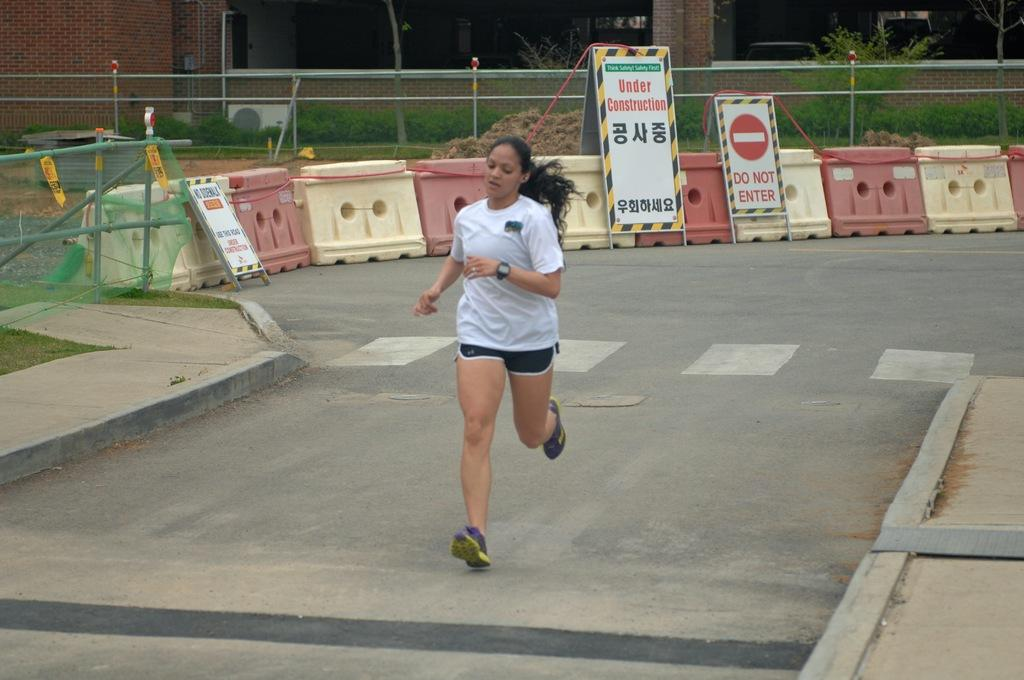Who is the main subject in the image? There is a woman in the image. What is the woman wearing? The woman is wearing a white t-shirt. What is the woman doing in the image? The woman is running on a path. What objects can be seen in the image related to traffic control? There are plastic traffic barriers in the image. What other objects can be seen in the image? There are boards and a fence in the image. What type of natural elements are present in the image? There are plants in the image. What type of man-made structure is visible in the image? There is a building in the image. What type of ice can be seen melting on the woman's shirt in the image? There is no ice present on the woman's shirt in the image. 